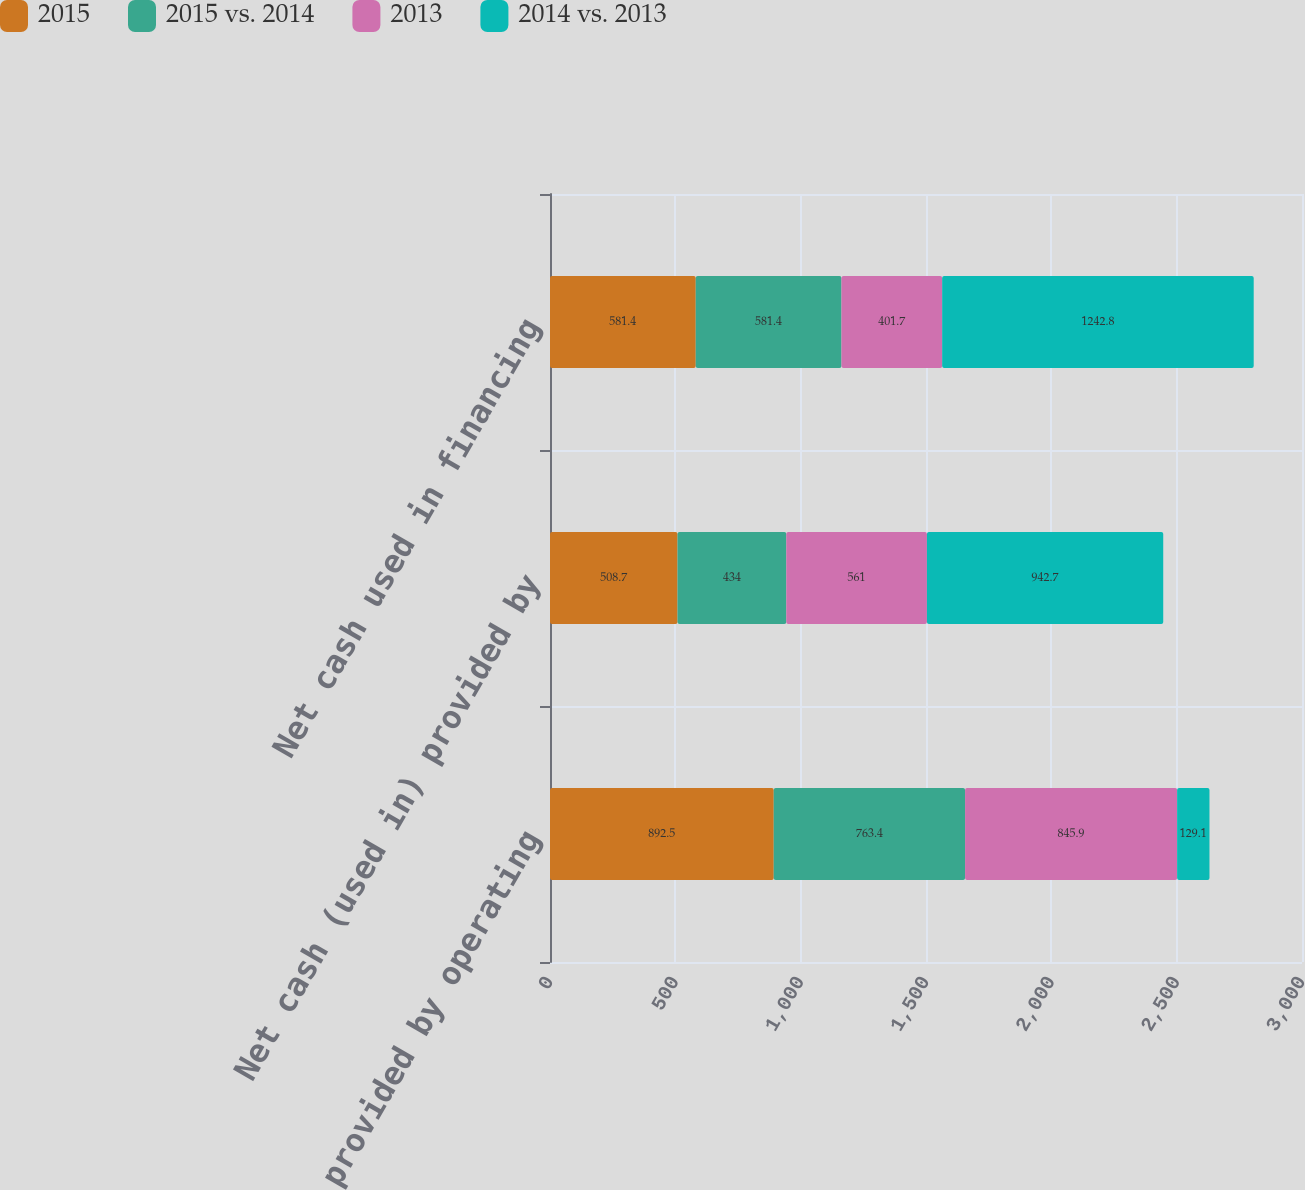Convert chart to OTSL. <chart><loc_0><loc_0><loc_500><loc_500><stacked_bar_chart><ecel><fcel>Net cash provided by operating<fcel>Net cash (used in) provided by<fcel>Net cash used in financing<nl><fcel>2015<fcel>892.5<fcel>508.7<fcel>581.4<nl><fcel>2015 vs. 2014<fcel>763.4<fcel>434<fcel>581.4<nl><fcel>2013<fcel>845.9<fcel>561<fcel>401.7<nl><fcel>2014 vs. 2013<fcel>129.1<fcel>942.7<fcel>1242.8<nl></chart> 